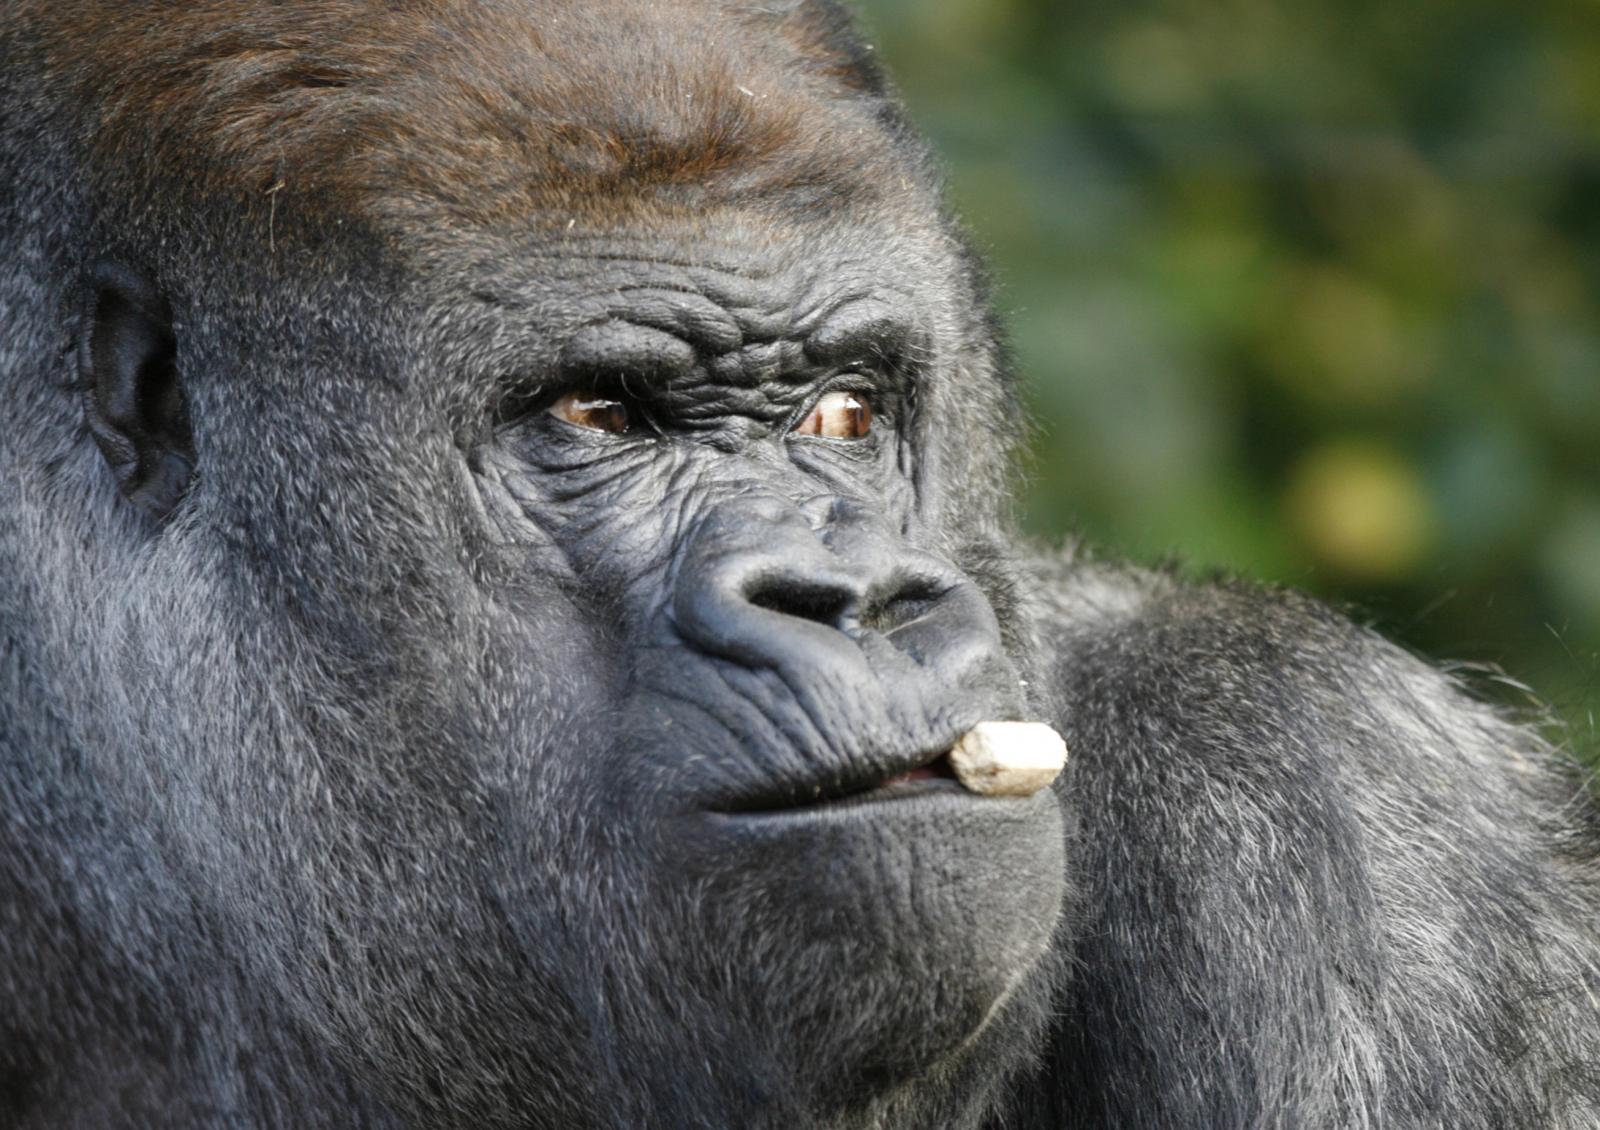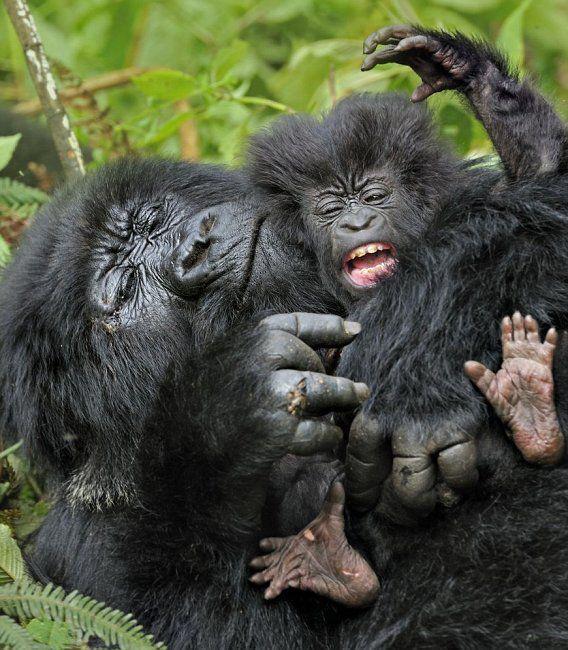The first image is the image on the left, the second image is the image on the right. Evaluate the accuracy of this statement regarding the images: "The right image includes a fluffy baby gorilla with its tongue visible.". Is it true? Answer yes or no. Yes. The first image is the image on the left, the second image is the image on the right. For the images shown, is this caption "There is a large gorilla in one image and at least a baby gorilla in the other image." true? Answer yes or no. Yes. 